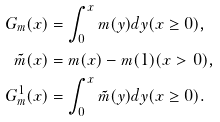<formula> <loc_0><loc_0><loc_500><loc_500>G _ { m } ( x ) & = \int _ { 0 } ^ { x } m ( y ) d y ( x \geq 0 ) , \\ \tilde { m } ( x ) & = m ( x ) - m ( 1 ) ( x > 0 ) , \\ G ^ { 1 } _ { m } ( x ) & = \int _ { 0 } ^ { x } \tilde { m } ( y ) d y ( x \geq 0 ) .</formula> 